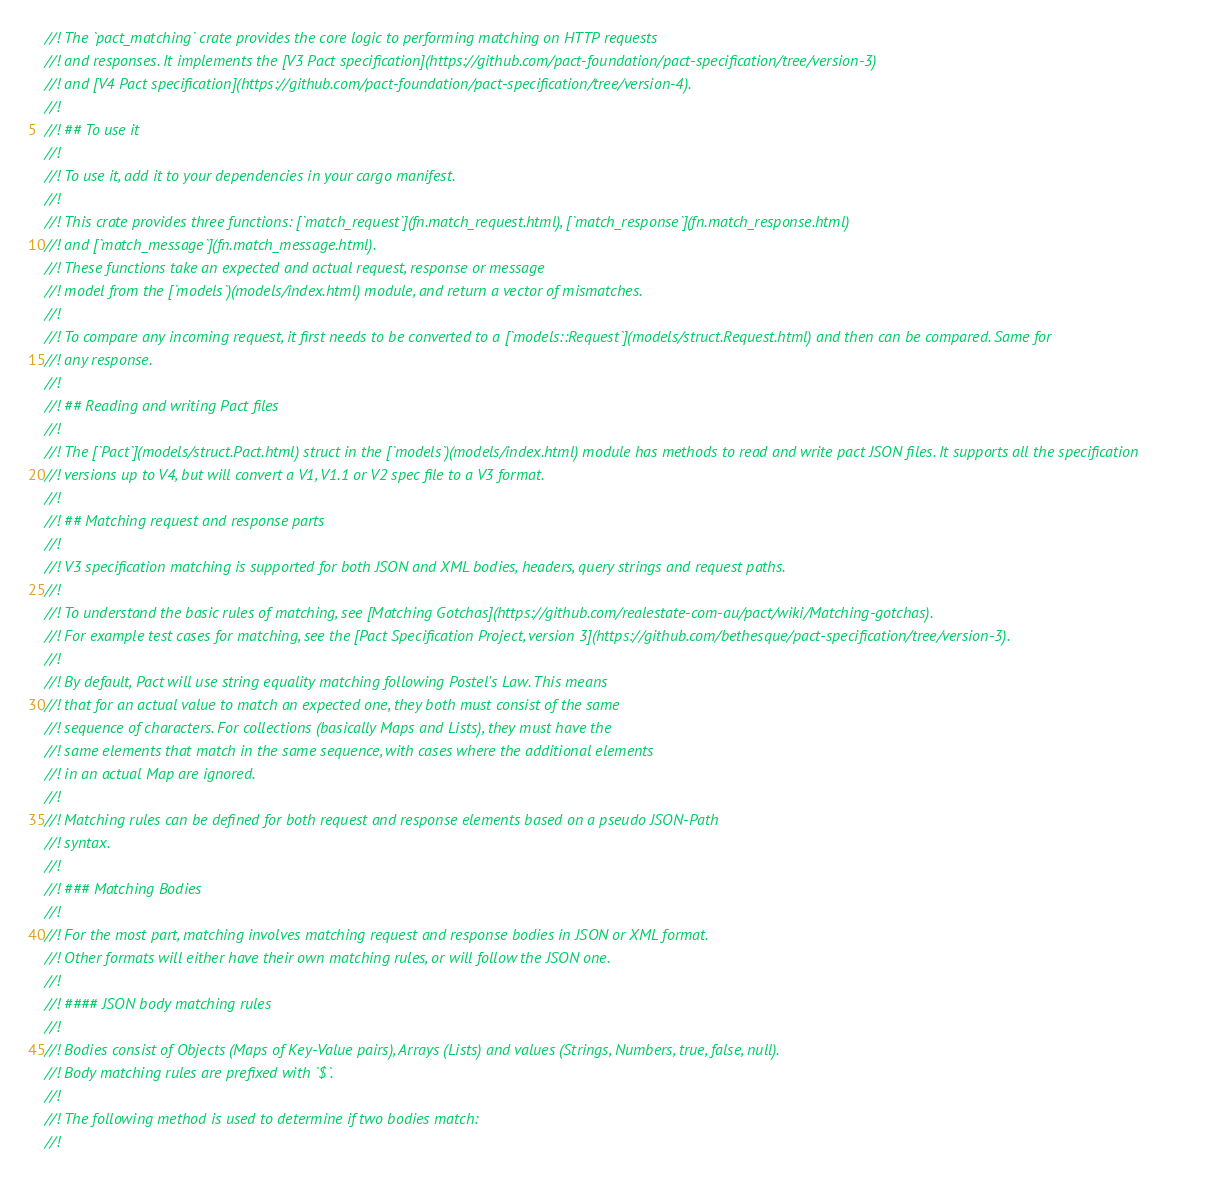<code> <loc_0><loc_0><loc_500><loc_500><_Rust_>//! The `pact_matching` crate provides the core logic to performing matching on HTTP requests
//! and responses. It implements the [V3 Pact specification](https://github.com/pact-foundation/pact-specification/tree/version-3)
//! and [V4 Pact specification](https://github.com/pact-foundation/pact-specification/tree/version-4).
//!
//! ## To use it
//!
//! To use it, add it to your dependencies in your cargo manifest.
//!
//! This crate provides three functions: [`match_request`](fn.match_request.html), [`match_response`](fn.match_response.html)
//! and [`match_message`](fn.match_message.html).
//! These functions take an expected and actual request, response or message
//! model from the [`models`)(models/index.html) module, and return a vector of mismatches.
//!
//! To compare any incoming request, it first needs to be converted to a [`models::Request`](models/struct.Request.html) and then can be compared. Same for
//! any response.
//!
//! ## Reading and writing Pact files
//!
//! The [`Pact`](models/struct.Pact.html) struct in the [`models`)(models/index.html) module has methods to read and write pact JSON files. It supports all the specification
//! versions up to V4, but will convert a V1, V1.1 or V2 spec file to a V3 format.
//!
//! ## Matching request and response parts
//!
//! V3 specification matching is supported for both JSON and XML bodies, headers, query strings and request paths.
//!
//! To understand the basic rules of matching, see [Matching Gotchas](https://github.com/realestate-com-au/pact/wiki/Matching-gotchas).
//! For example test cases for matching, see the [Pact Specification Project, version 3](https://github.com/bethesque/pact-specification/tree/version-3).
//!
//! By default, Pact will use string equality matching following Postel's Law. This means
//! that for an actual value to match an expected one, they both must consist of the same
//! sequence of characters. For collections (basically Maps and Lists), they must have the
//! same elements that match in the same sequence, with cases where the additional elements
//! in an actual Map are ignored.
//!
//! Matching rules can be defined for both request and response elements based on a pseudo JSON-Path
//! syntax.
//!
//! ### Matching Bodies
//!
//! For the most part, matching involves matching request and response bodies in JSON or XML format.
//! Other formats will either have their own matching rules, or will follow the JSON one.
//!
//! #### JSON body matching rules
//!
//! Bodies consist of Objects (Maps of Key-Value pairs), Arrays (Lists) and values (Strings, Numbers, true, false, null).
//! Body matching rules are prefixed with `$`.
//!
//! The following method is used to determine if two bodies match:
//!</code> 